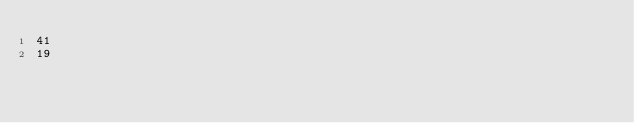<code> <loc_0><loc_0><loc_500><loc_500><_SQL_>41
19</code> 